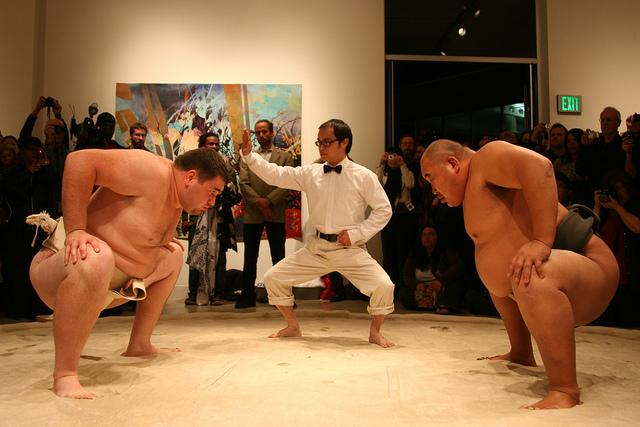This activity is most associated with which people group? Please explain your reasoning. japanese. The men are participating in sumo wrestling. i did an internet search for the county of origin of sumo wrestling. 